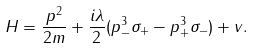<formula> <loc_0><loc_0><loc_500><loc_500>H = \frac { { p } ^ { 2 } } { 2 m } + \frac { i \lambda } { 2 } ( p _ { - } ^ { 3 } \sigma _ { + } - p _ { + } ^ { 3 } \sigma _ { - } ) + v .</formula> 